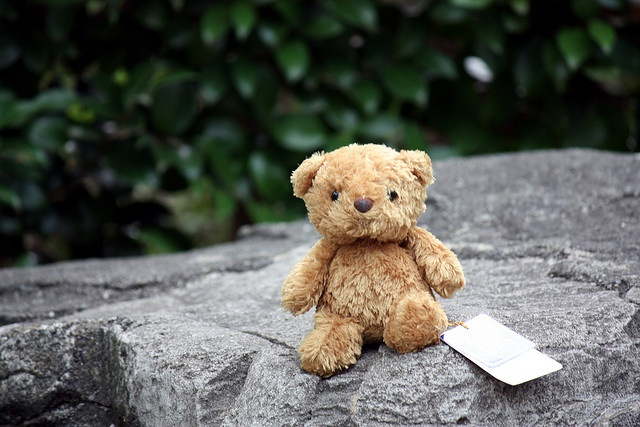Describe the objects in this image and their specific colors. I can see a teddy bear in black, tan, and gray tones in this image. 